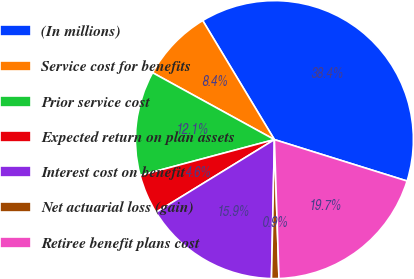<chart> <loc_0><loc_0><loc_500><loc_500><pie_chart><fcel>(In millions)<fcel>Service cost for benefits<fcel>Prior service cost<fcel>Expected return on plan assets<fcel>Interest cost on benefit<fcel>Net actuarial loss (gain)<fcel>Retiree benefit plans cost<nl><fcel>38.45%<fcel>8.38%<fcel>12.14%<fcel>4.62%<fcel>15.9%<fcel>0.86%<fcel>19.66%<nl></chart> 